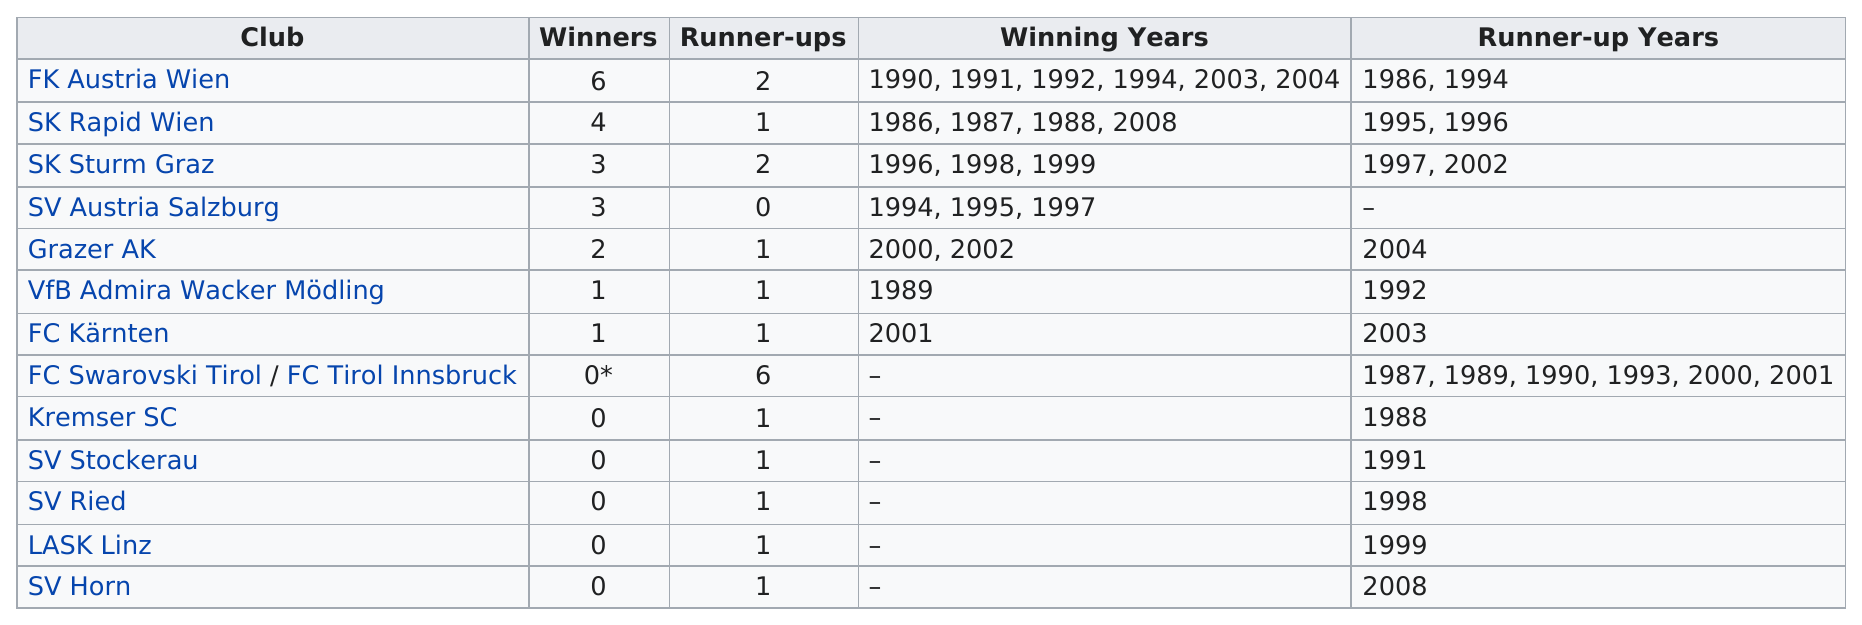Mention a couple of crucial points in this snapshot. I am not sure what you are asking for. Could you please provide more context or clarify your question? Out of the 6 teams that have never won the Supercup, how many have never won it? FC Swarovski Tirol/FC Tirol Innsbruck has played in the most Supercups without winning. The Supercup was cancelled in the year 2009. Sk Sturm Graz has been the runner-up a total of two times. 